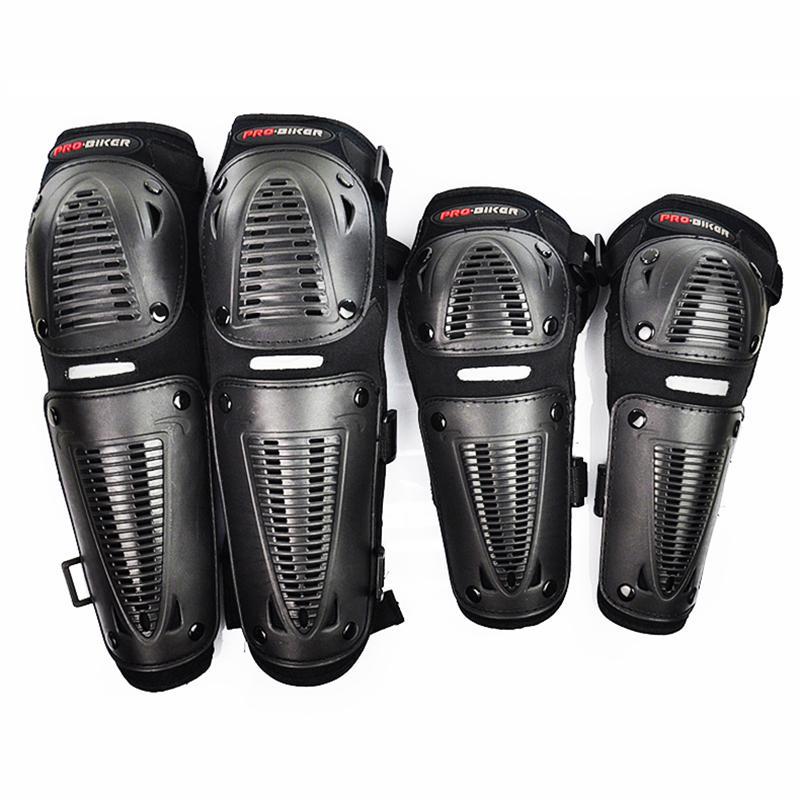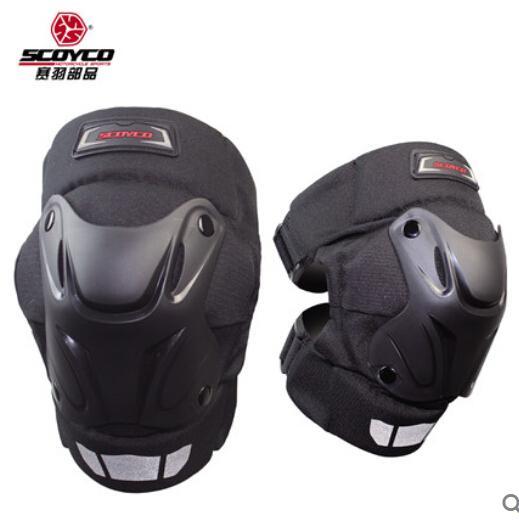The first image is the image on the left, the second image is the image on the right. Analyze the images presented: Is the assertion "Exactly eight pieces of equipment are shown in groups of four each." valid? Answer yes or no. No. The first image is the image on the left, the second image is the image on the right. Examine the images to the left and right. Is the description "One image contains just one pair of black knee pads." accurate? Answer yes or no. Yes. 